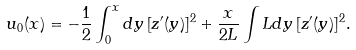<formula> <loc_0><loc_0><loc_500><loc_500>u _ { 0 } ( x ) = - \frac { 1 } { 2 } \int _ { 0 } ^ { x } d y \, [ z ^ { \prime } ( y ) ] ^ { 2 } + \frac { x } { 2 L } \int L d y \, [ z ^ { \prime } ( y ) ] ^ { 2 } .</formula> 